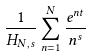<formula> <loc_0><loc_0><loc_500><loc_500>\frac { 1 } { H _ { N , s } } \sum _ { n = 1 } ^ { N } \frac { e ^ { n t } } { n ^ { s } }</formula> 